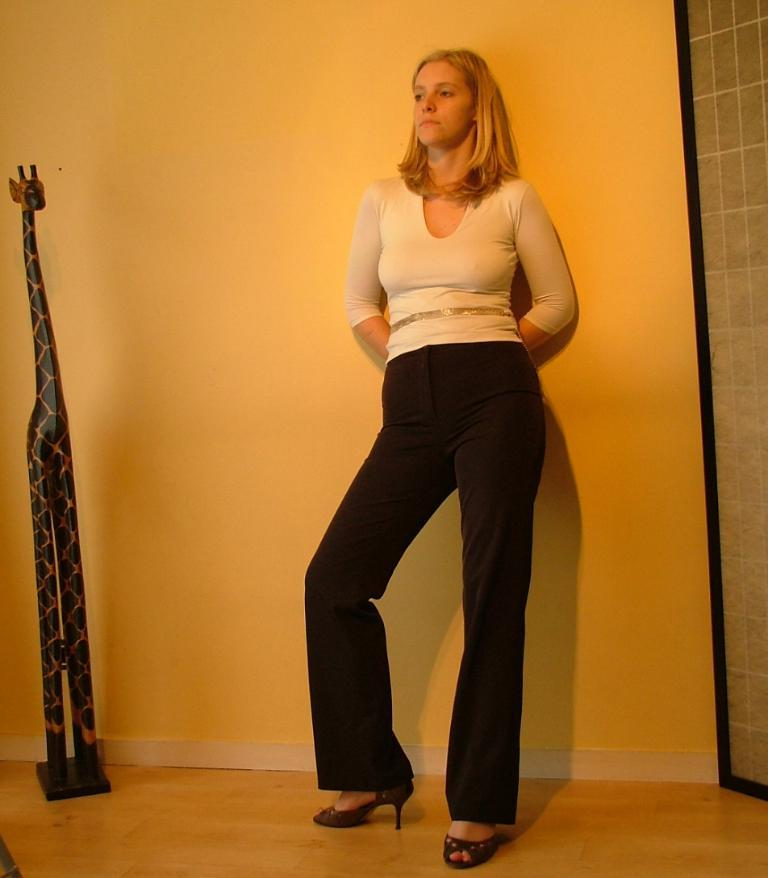What is the main subject in the image? There is a woman standing in the image. What can be seen on both sides of the woman? There are objects on both sides of the image. What is visible in the background of the image? A wall is visible in the background of the image. What type of oil is being used by the woman in the image? There is no oil present in the image, nor is the woman using any oil. 